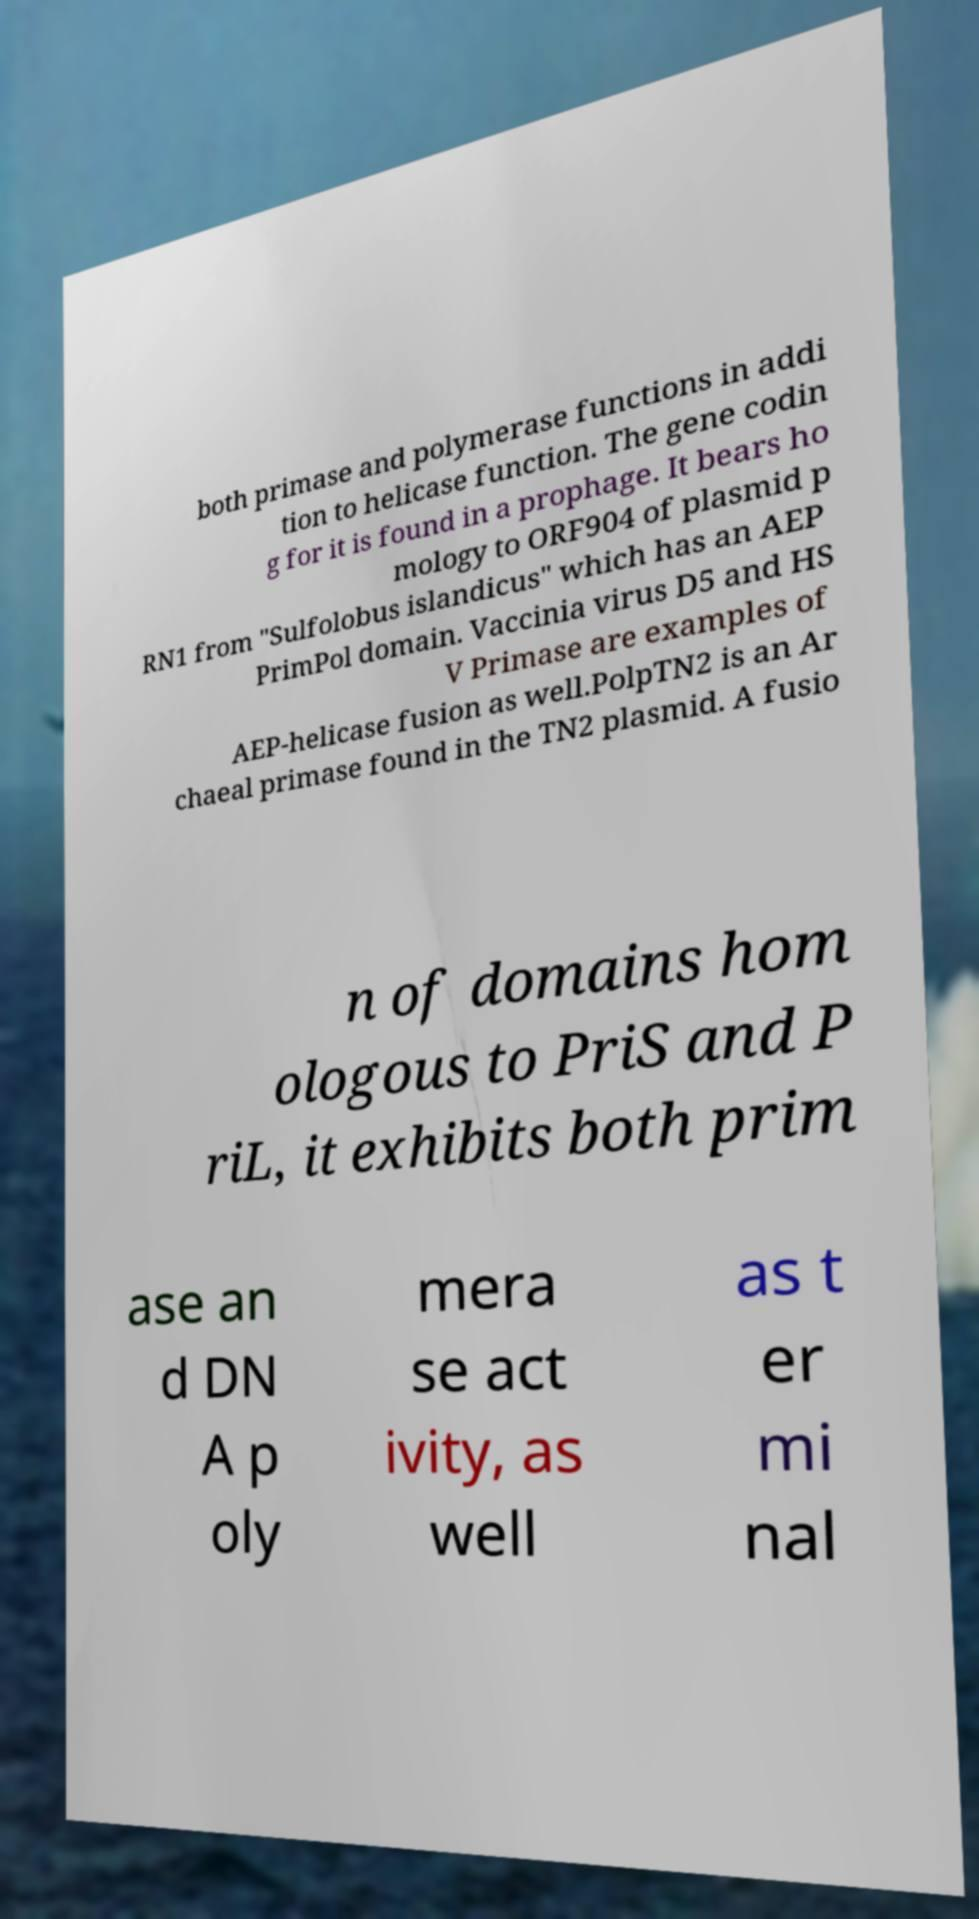Please identify and transcribe the text found in this image. both primase and polymerase functions in addi tion to helicase function. The gene codin g for it is found in a prophage. It bears ho mology to ORF904 of plasmid p RN1 from "Sulfolobus islandicus" which has an AEP PrimPol domain. Vaccinia virus D5 and HS V Primase are examples of AEP-helicase fusion as well.PolpTN2 is an Ar chaeal primase found in the TN2 plasmid. A fusio n of domains hom ologous to PriS and P riL, it exhibits both prim ase an d DN A p oly mera se act ivity, as well as t er mi nal 